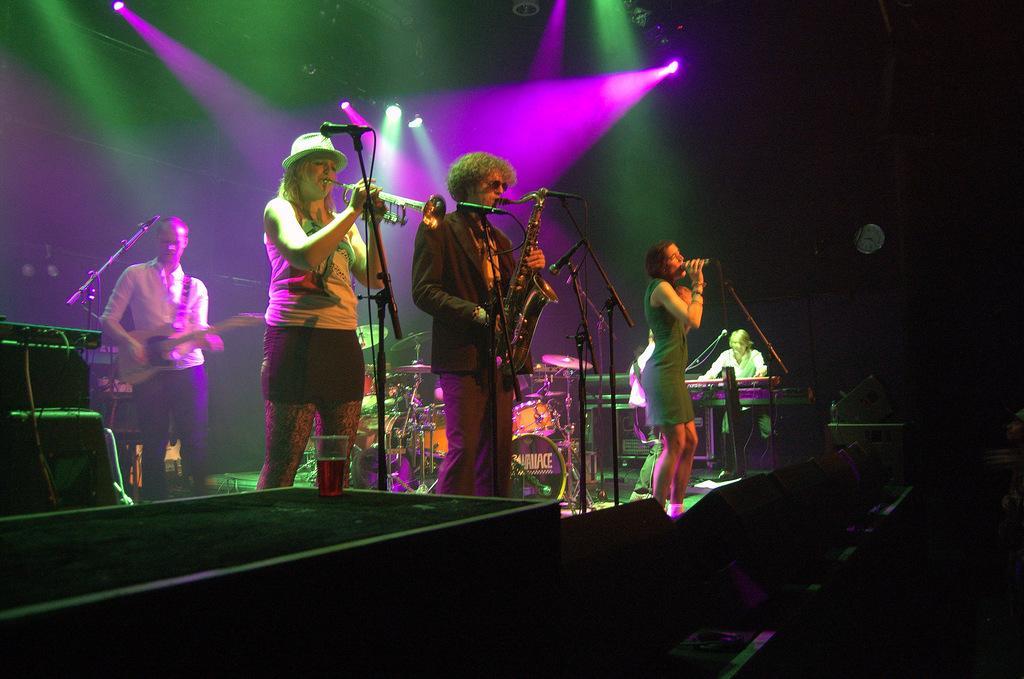In one or two sentences, can you explain what this image depicts? In this image we can see few persons playing musical instruments. We can see a person holding a mic and singing. Behind the persons we can see musical instruments. At the top we can see the lights. On the left side, we can see few objects. The background of the image is dark. 